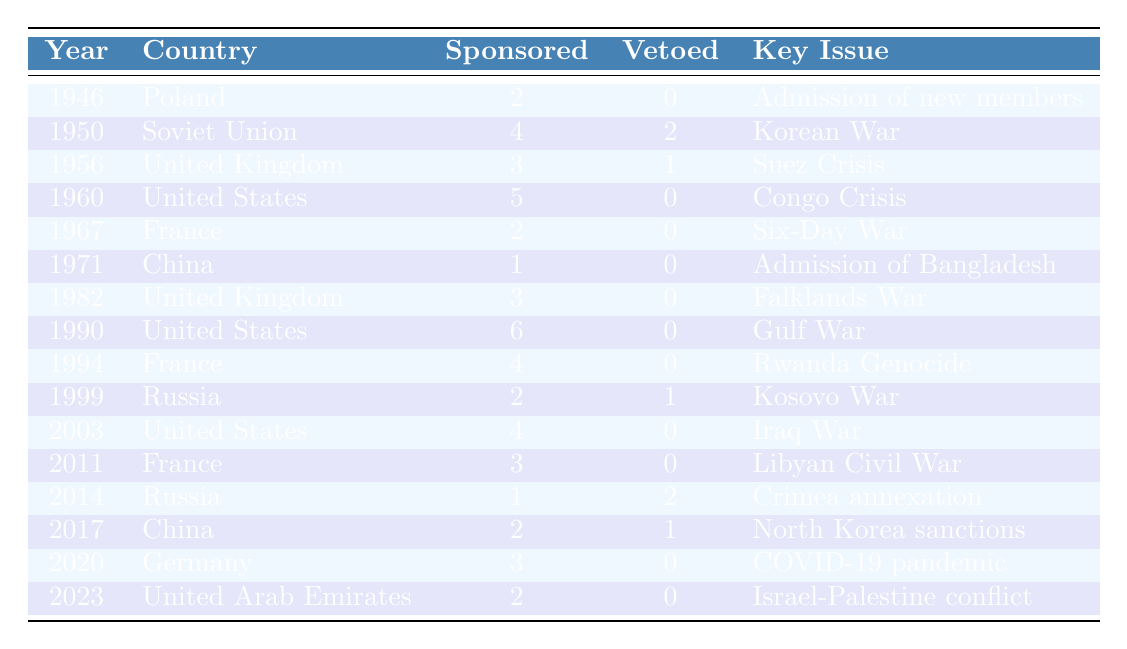What country sponsored the most resolutions in a single year? The country that sponsored the most resolutions in a single year is the United States in 1990, with a total of 6 resolutions.
Answer: United States How many resolutions did the United Kingdom sponsor in total? The United Kingdom sponsored a total of 6 resolutions (3 in 1956 and 3 in 1982).
Answer: 6 Did China veto any resolutions from 1946 to 2023? Yes, China vetoed 1 resolution in 2017.
Answer: Yes Which country sponsored resolutions related to the Iraq War? The United States sponsored resolutions related to the Iraq War in 2003.
Answer: United States Which two countries had the highest number of vetoes? The countries with the highest number of vetoes are the Soviet Union (2 in 1950) and Russia (2 in 2014), both having 2 vetoes each.
Answer: Soviet Union and Russia What was the major issue of the resolution sponsored by Poland in 1946? The major issue of the resolution sponsored by Poland in 1946 was the admission of new members to the UN.
Answer: Admission of new members How many resolutions were sponsored by France across the years? France sponsored a total of 9 resolutions (2 in 1967, 4 in 1994, and 3 in 2011).
Answer: 9 Which countries had resolutions sponsored in 2020 and what was the key issue? Germany sponsored 3 resolutions in 2020, with the key issue being the COVID-19 pandemic.
Answer: Germany, COVID-19 pandemic Compare the number of resolutions sponsored by the United States and the Soviet Union. The United States sponsored a total of 15 resolutions (5 in 1960, 6 in 1990, and 4 in 2003), while the Soviet Union sponsored 4 resolutions (4 in 1950).
Answer: United States (15), Soviet Union (4) What is the average number of vetoes per country that sponsored resolutions in the table? There are 10 instances of countries sponsoring resolutions across the years, with a total of 7 vetoes. The average is calculated as 7 vetoes / 10 instances = 0.7.
Answer: 0.7 Which country had the least number of resolutions sponsored and what was the key issue? China had the least number of resolutions sponsored, with only 1 resolution in 1971, concerning the admission of Bangladesh.
Answer: China, Admission of Bangladesh 